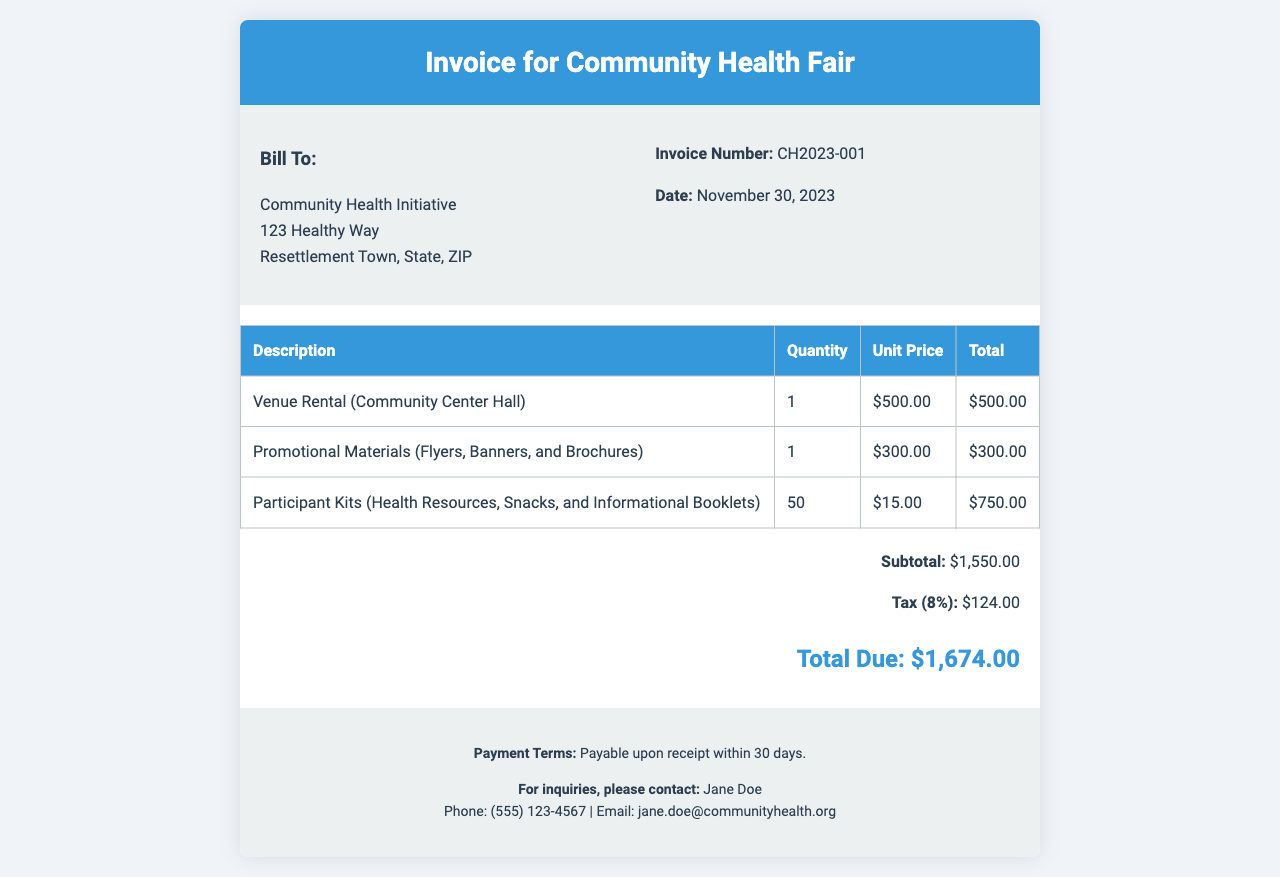What is the invoice number? The invoice number is specified at the top of the document, listed under the invoice information.
Answer: CH2023-001 What is the date of the invoice? The date is mentioned in the invoice details section, indicating when the invoice was issued.
Answer: November 30, 2023 What is the total cost of the venue rental? The total cost for the venue rental is listed in the invoice table under the corresponding description.
Answer: $500.00 How many participant kits were included in the invoice? The quantity of participant kits is stated in the invoice table, next to the item description.
Answer: 50 What is the subtotal amount before tax? The subtotal represents the sum of all line item totals before any tax is applied, found in the summary section.
Answer: $1,550.00 What percentage is the tax applied to the subtotal? The tax is expressed as a percentage of the subtotal in the summarization area of the invoice.
Answer: 8% Who can be contacted for inquiries regarding the invoice? The contact person for inquiries is listed in the footer of the document along with their contact details.
Answer: Jane Doe What is the total amount due? The total due is the final amount that needs to be paid, summarized at the bottom of the invoice.
Answer: $1,674.00 What are the payment terms stated in the invoice? The payment terms outline when the payment is expected and are explicitly mentioned in the footer section.
Answer: Payable upon receipt within 30 days 